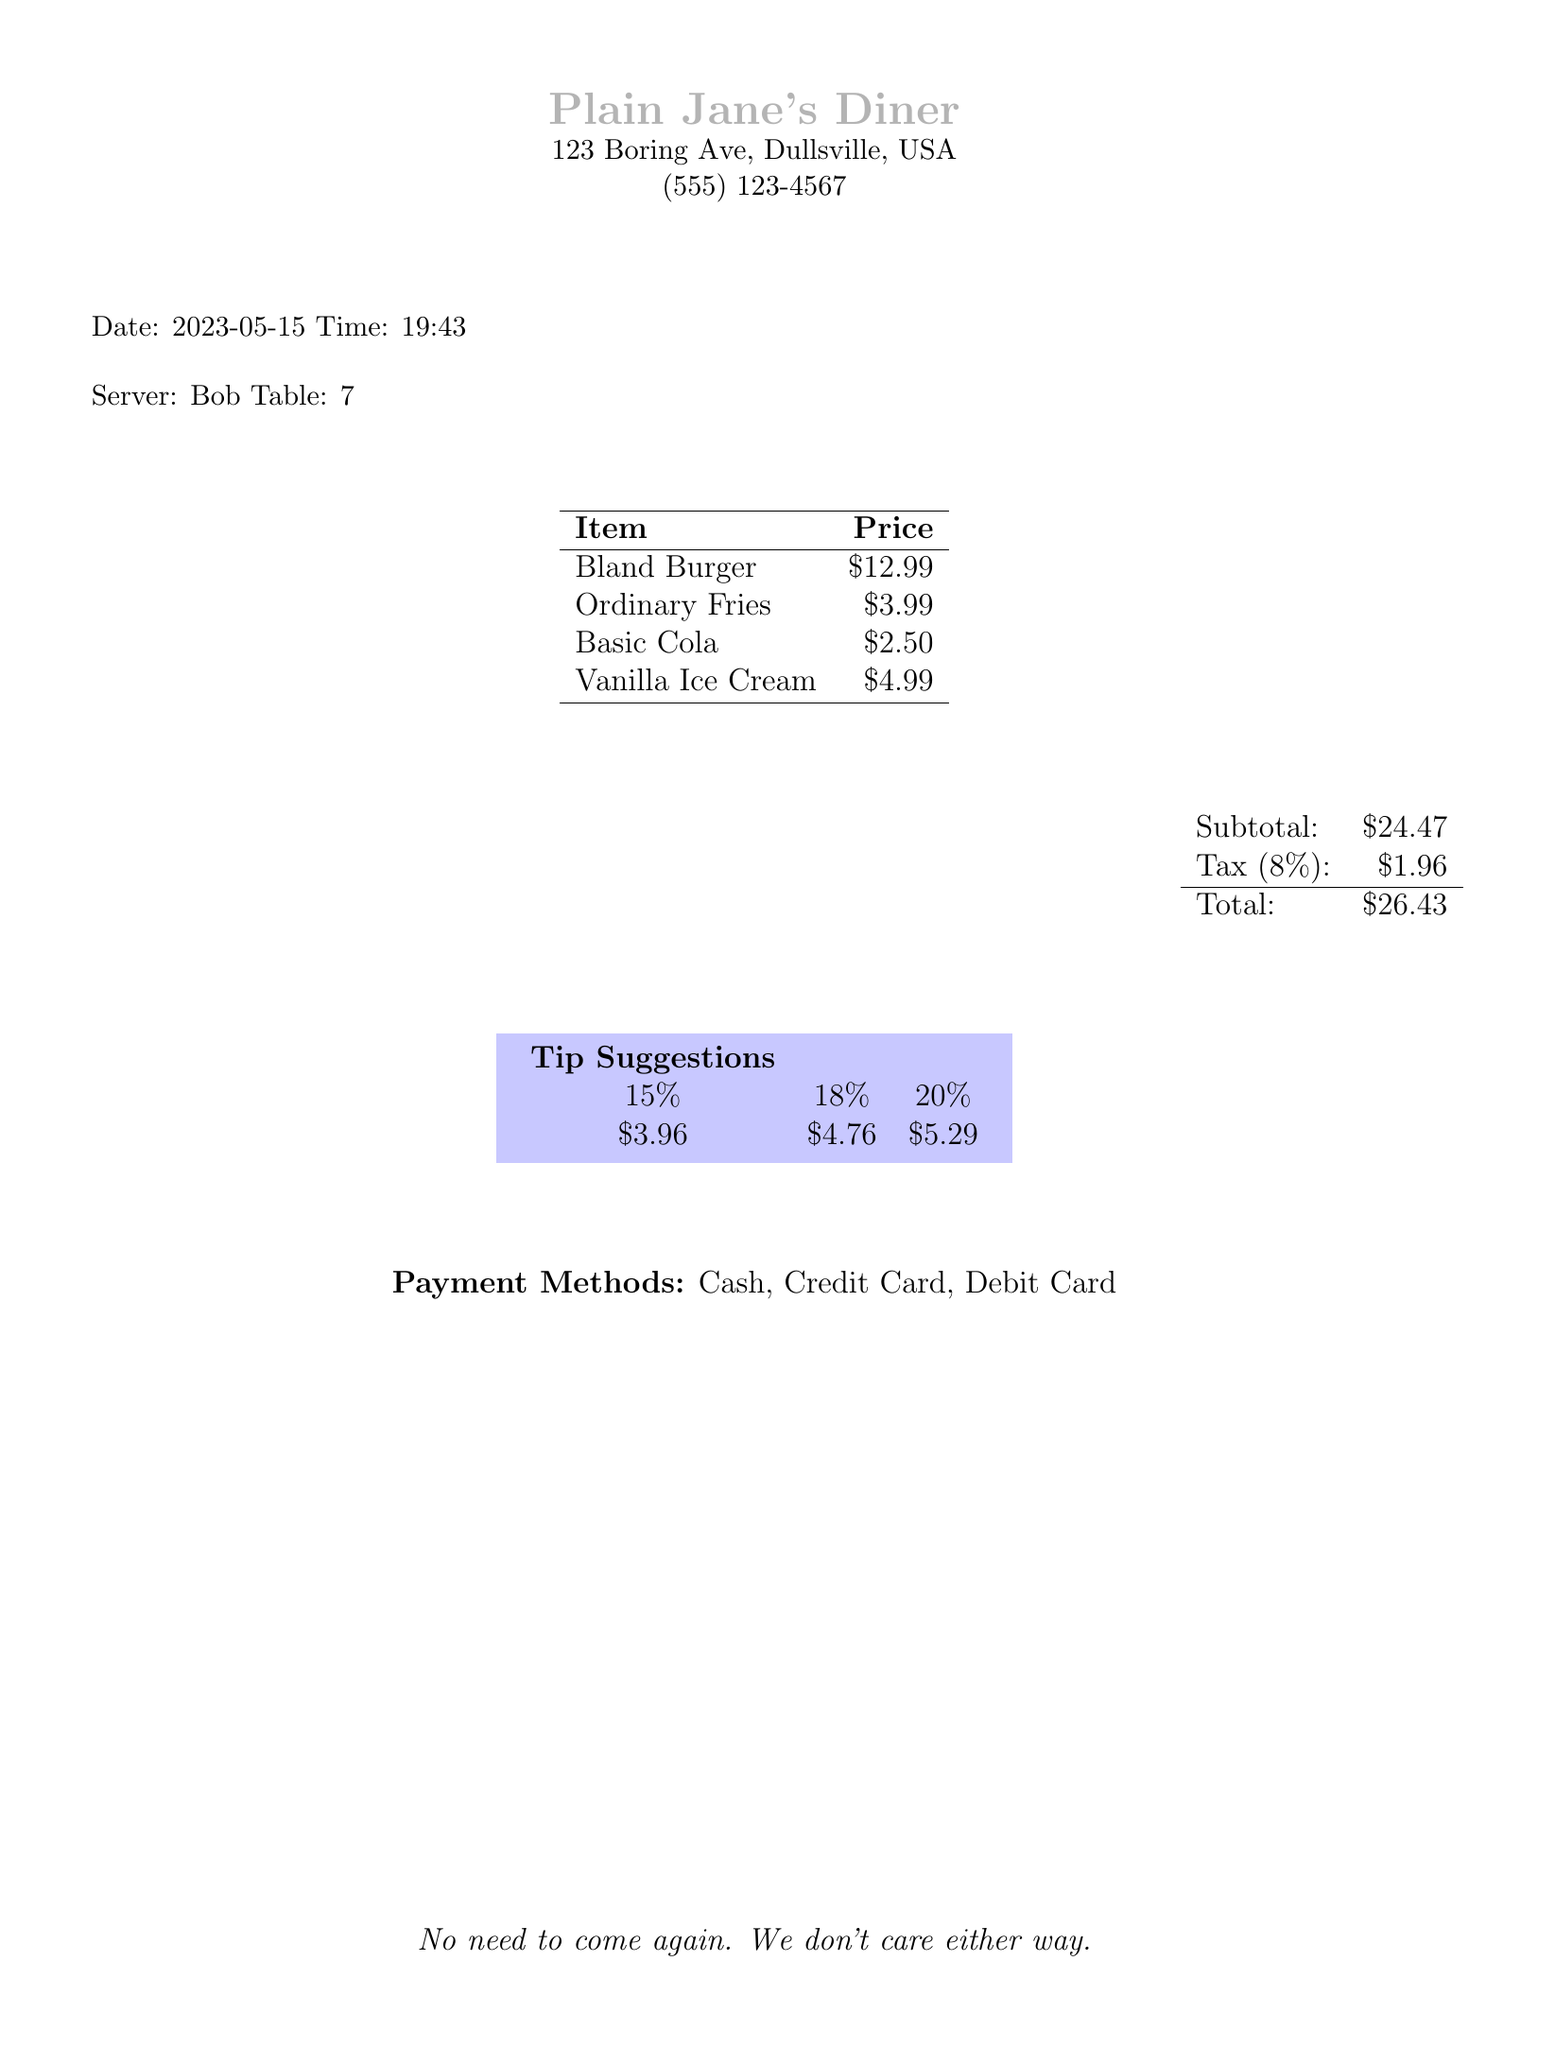What is the name of the restaurant? The name of the restaurant is located at the top of the document, presented prominently.
Answer: Plain Jane's Diner What is the date of the receipt? The date is listed clearly within the document.
Answer: 2023-05-15 Who was the server? The name of the server is mentioned in the section detailing service information.
Answer: Bob What is the subtotal amount? The subtotal is calculated before tax and is displayed in a distinct section.
Answer: 24.47 What is the tax amount? The tax amount is shown distinctly in the financial summary of the receipt.
Answer: 1.96 How much is the total bill? The total bill includes the subtotal and taxes displayed in the totals section.
Answer: 26.43 What is the price of the Bland Burger? The price for each individual menu item is listed next to the item name.
Answer: 12.99 What is the percentage for the highest tip suggestion? The tip suggestions are outlined with various percentages in the receipt.
Answer: 20% What payment methods are accepted? The accepted payment methods are listed toward the end of the document.
Answer: Cash, Credit Card, Debit Card 